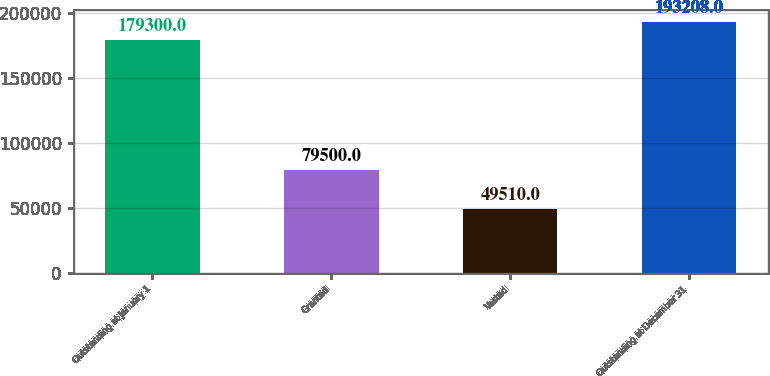Convert chart to OTSL. <chart><loc_0><loc_0><loc_500><loc_500><bar_chart><fcel>Outstanding at January 1<fcel>Granted<fcel>Vested<fcel>Outstanding at December 31<nl><fcel>179300<fcel>79500<fcel>49510<fcel>193208<nl></chart> 